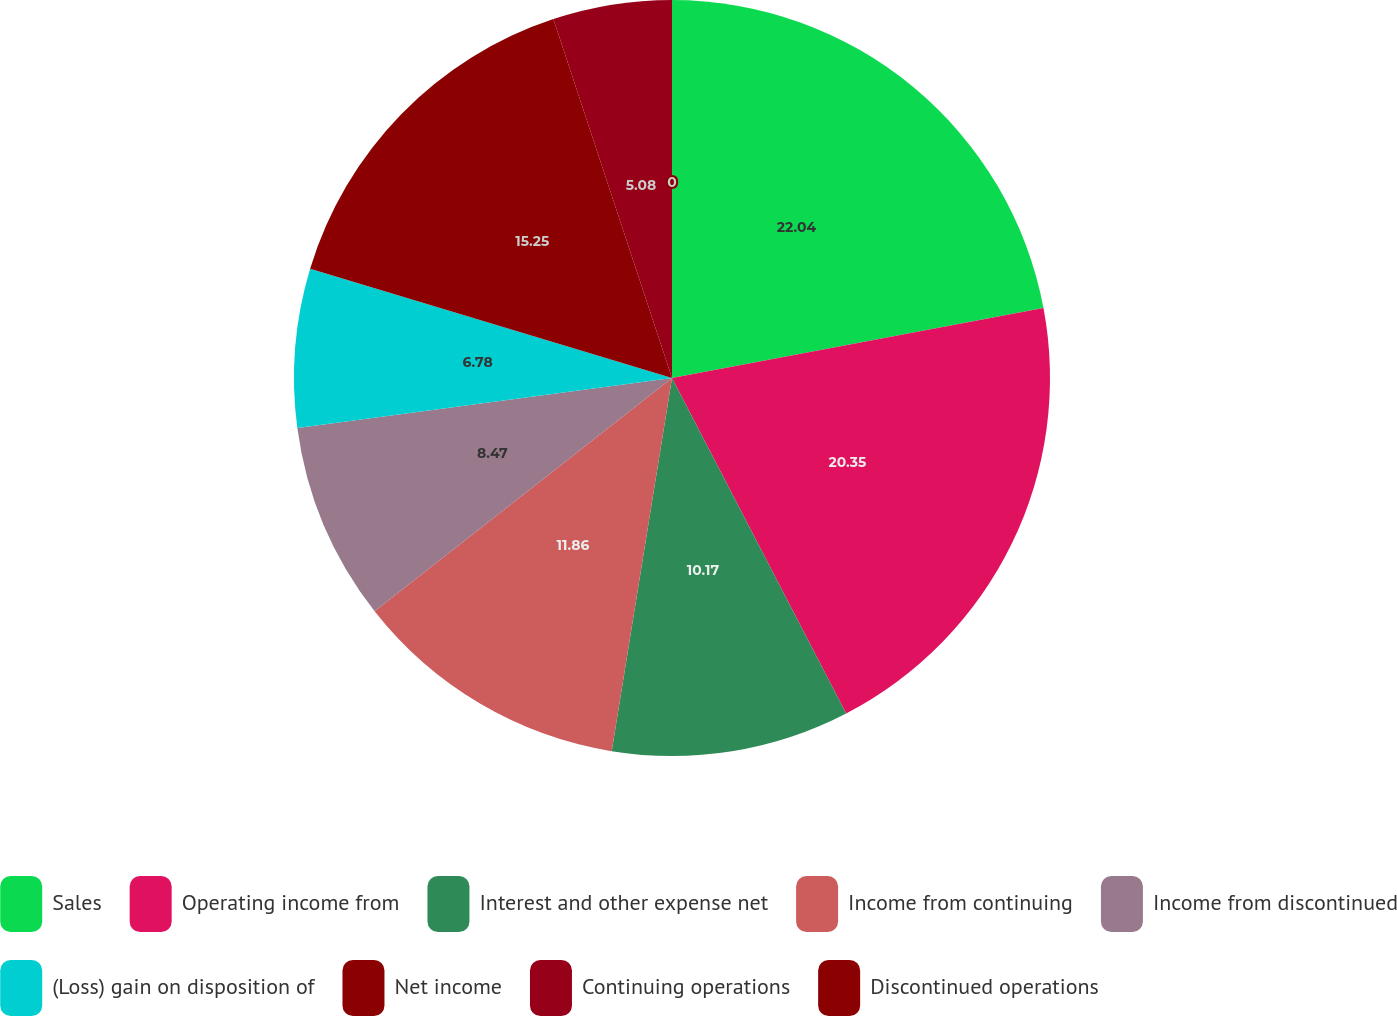<chart> <loc_0><loc_0><loc_500><loc_500><pie_chart><fcel>Sales<fcel>Operating income from<fcel>Interest and other expense net<fcel>Income from continuing<fcel>Income from discontinued<fcel>(Loss) gain on disposition of<fcel>Net income<fcel>Continuing operations<fcel>Discontinued operations<nl><fcel>22.03%<fcel>20.34%<fcel>10.17%<fcel>11.86%<fcel>8.47%<fcel>6.78%<fcel>15.25%<fcel>5.08%<fcel>0.0%<nl></chart> 